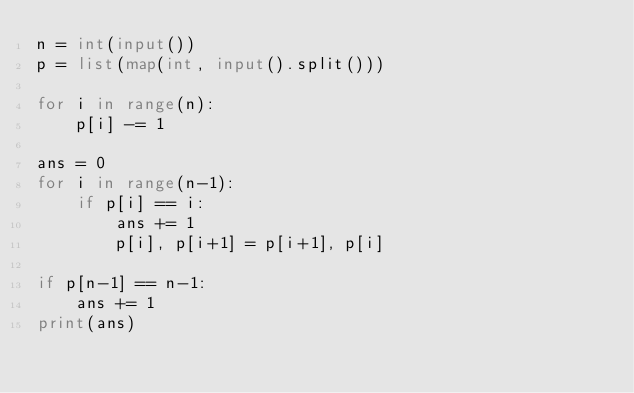<code> <loc_0><loc_0><loc_500><loc_500><_Python_>n = int(input())
p = list(map(int, input().split()))

for i in range(n):
    p[i] -= 1

ans = 0
for i in range(n-1):
    if p[i] == i:
        ans += 1
        p[i], p[i+1] = p[i+1], p[i]

if p[n-1] == n-1:
    ans += 1
print(ans)
</code> 